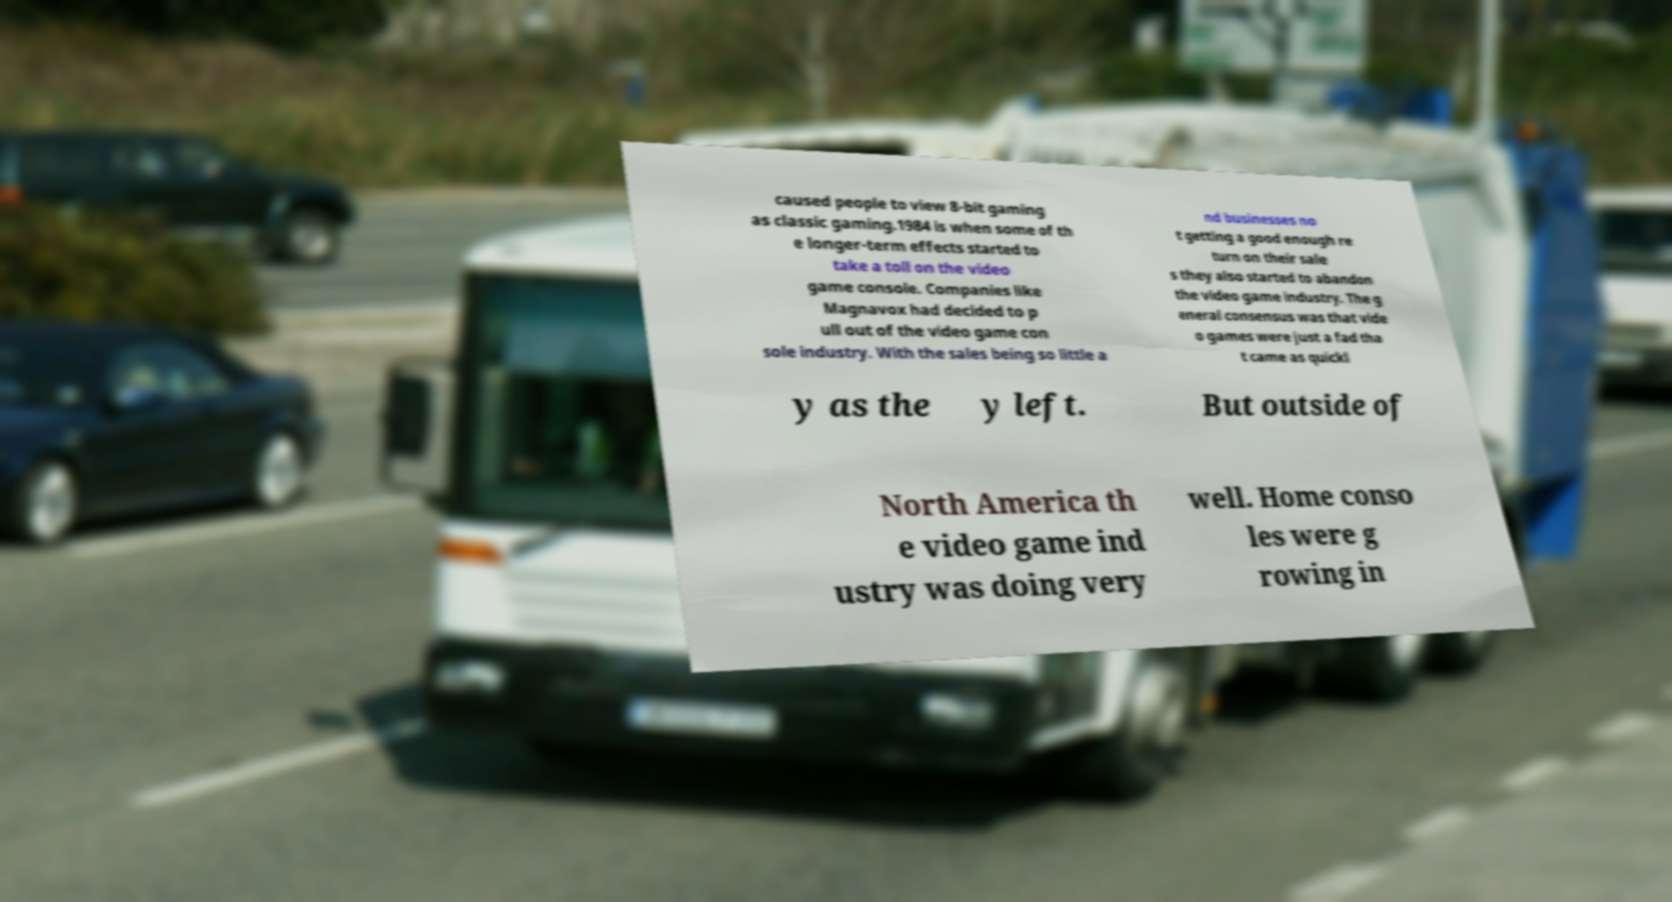Please read and relay the text visible in this image. What does it say? caused people to view 8-bit gaming as classic gaming.1984 is when some of th e longer-term effects started to take a toll on the video game console. Companies like Magnavox had decided to p ull out of the video game con sole industry. With the sales being so little a nd businesses no t getting a good enough re turn on their sale s they also started to abandon the video game industry. The g eneral consensus was that vide o games were just a fad tha t came as quickl y as the y left. But outside of North America th e video game ind ustry was doing very well. Home conso les were g rowing in 